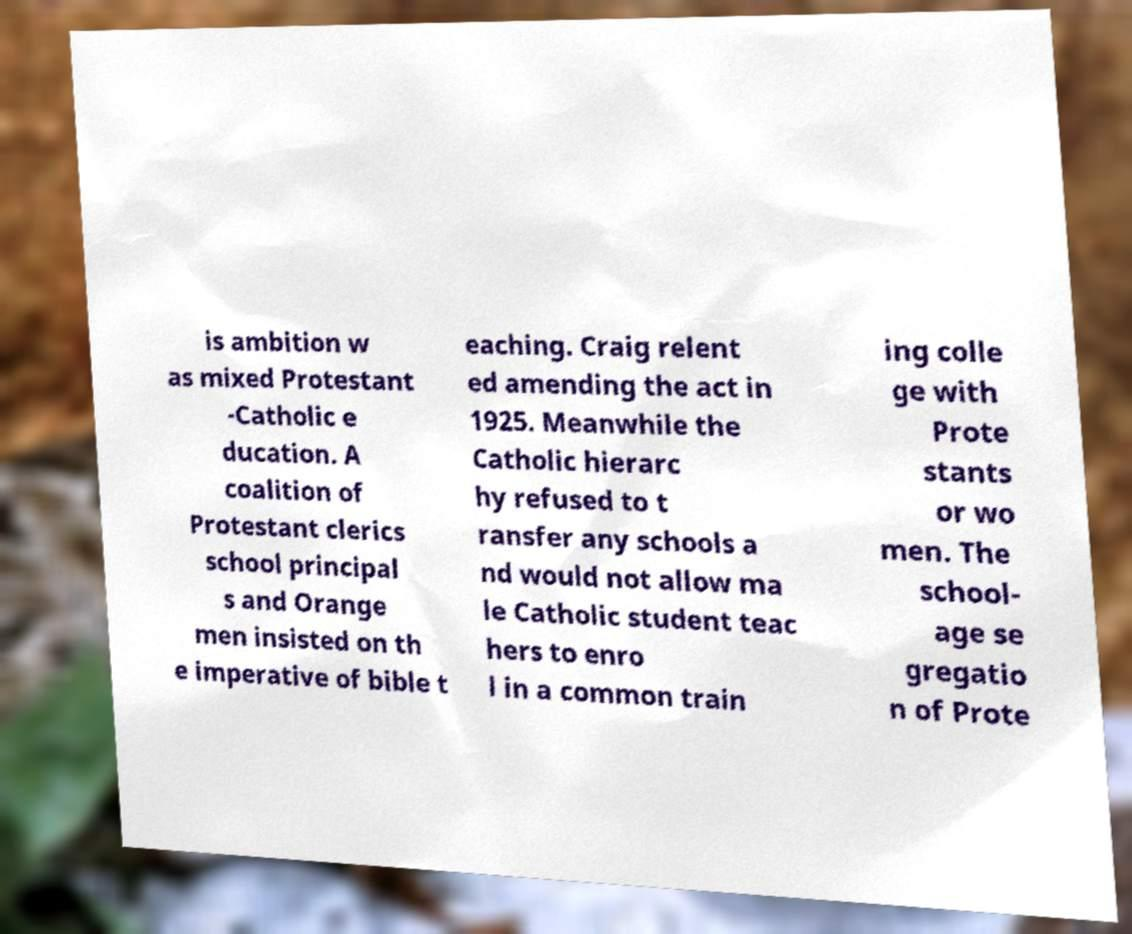I need the written content from this picture converted into text. Can you do that? is ambition w as mixed Protestant -Catholic e ducation. A coalition of Protestant clerics school principal s and Orange men insisted on th e imperative of bible t eaching. Craig relent ed amending the act in 1925. Meanwhile the Catholic hierarc hy refused to t ransfer any schools a nd would not allow ma le Catholic student teac hers to enro l in a common train ing colle ge with Prote stants or wo men. The school- age se gregatio n of Prote 